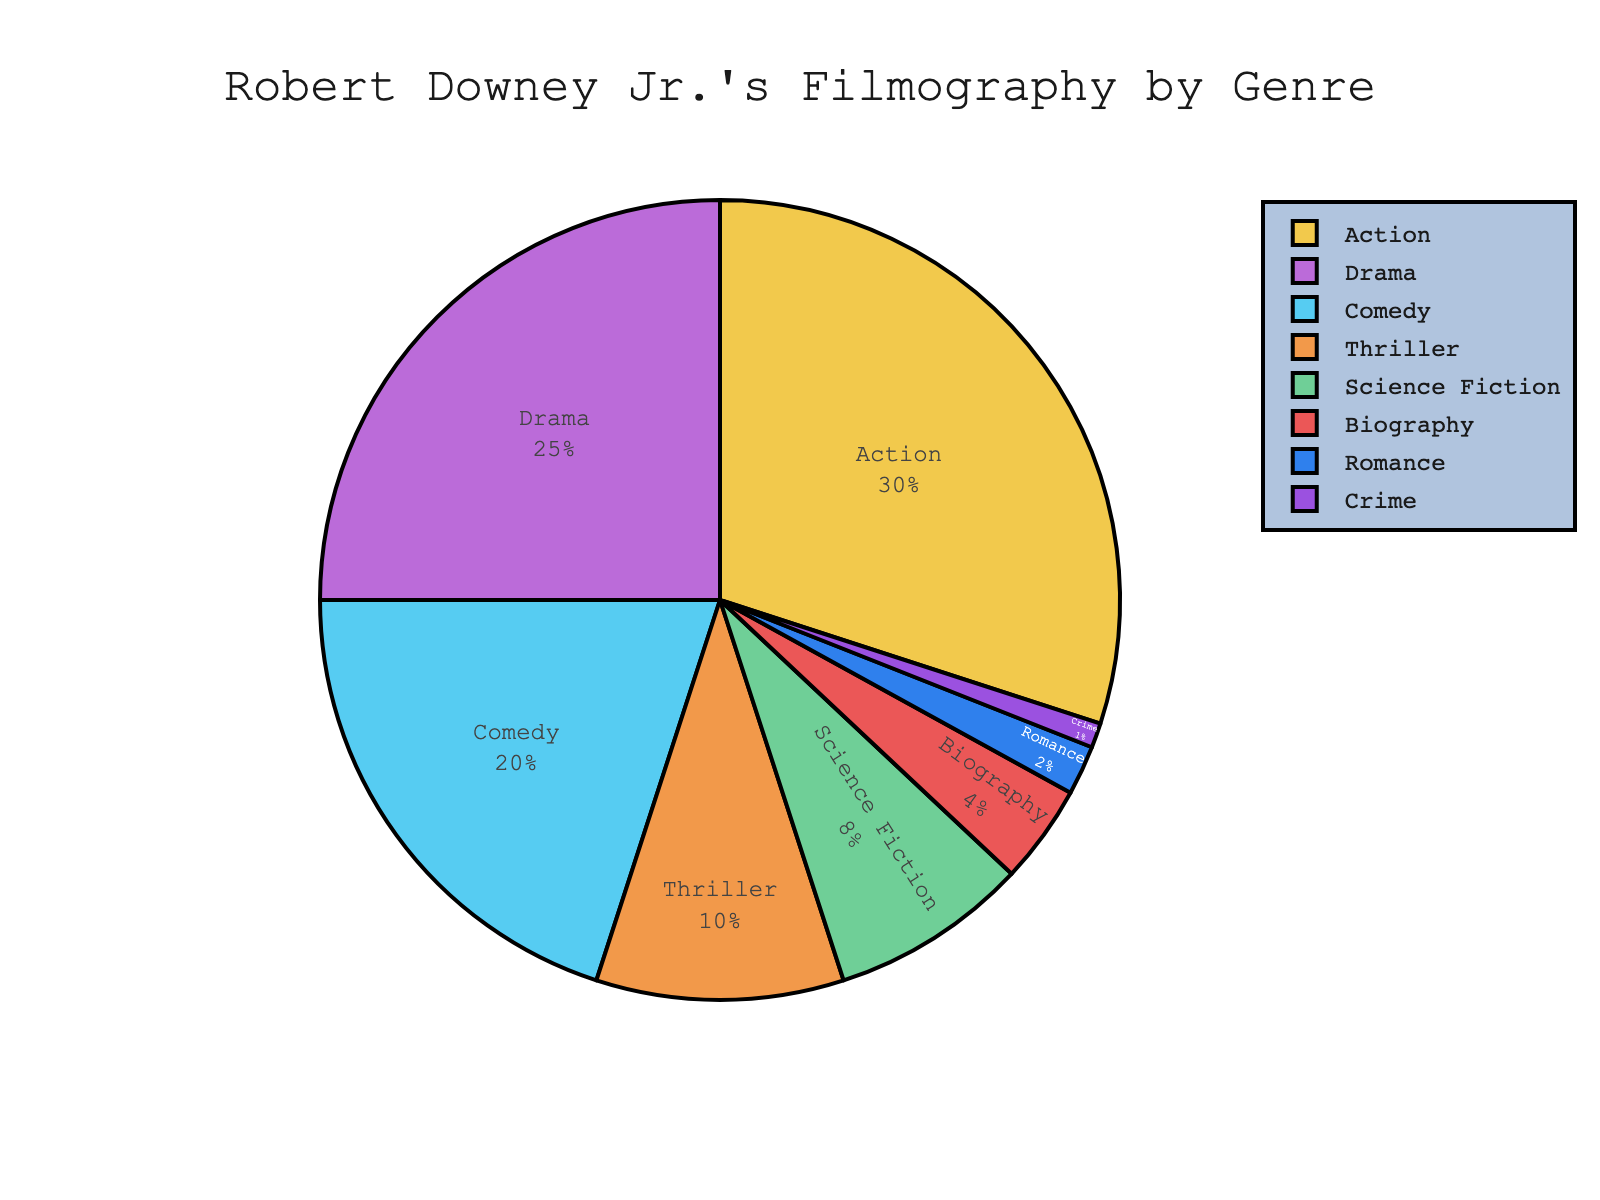What's the most common genre in Robert Downey Jr.'s filmography? The largest section is the one labeled with the highest percentage. Action has the highest percentage at 30%.
Answer: Action Which genre appears the least and what is its percentage? The smallest section is labeled with the lowest percentage. Crime has the smallest percentage at 1%.
Answer: Crime - 1% How much larger is the Action genre compared to the Romance genre? Subtract the percentage of the Romance genre from the Action genre. Action is 30% and Romance is 2%, so 30 - 2 = 28.
Answer: 28% If we combine the Drama and Comedy genres, what percentage of Robert Downey Jr.'s filmography do they represent? Add the percentages of Drama and Comedy. Drama is 25% and Comedy is 20%, so 25 + 20 = 45.
Answer: 45% Out of the Thriller and Science Fiction genres, which one occupies a larger space on the pie chart, and by what percentage? Compare the percentages of Thriller and Science Fiction. Thriller is 10% and Science Fiction is 8%, so Thriller is larger by 10 - 8 = 2.
Answer: Thriller - 2% What is the combined percentage of the genres that make up less than 10% of Robert Downey Jr.'s filmography? Add the percentages of genres that are less than 10%: Science Fiction (8%), Biography (4%), Romance (2%), Crime (1%). 8 + 4 + 2 + 1 = 15.
Answer: 15% Is Comedy or Biography a more prevalent genre in Robert Downey Jr.'s films? Compare the percentages of Comedy and Biography. Comedy is 20% and Biography is 4%, so Comedy is more prevalent.
Answer: Comedy What is the total percentage of Drama and Biography together? Add the percentages of Drama and Biography. Drama is 25% and Biography is 4%, so 25 + 4 = 29.
Answer: 29% Arrange the genres in descending order of their percentage contribution to Robert Downey Jr.'s filmography. List the genres in order from highest to lowest percentage. Action (30%), Drama (25%), Comedy (20%), Thriller (10%), Science Fiction (8%), Biography (4%), Romance (2%), Crime (1%).
Answer: Action, Drama, Comedy, Thriller, Science Fiction, Biography, Romance, Crime 